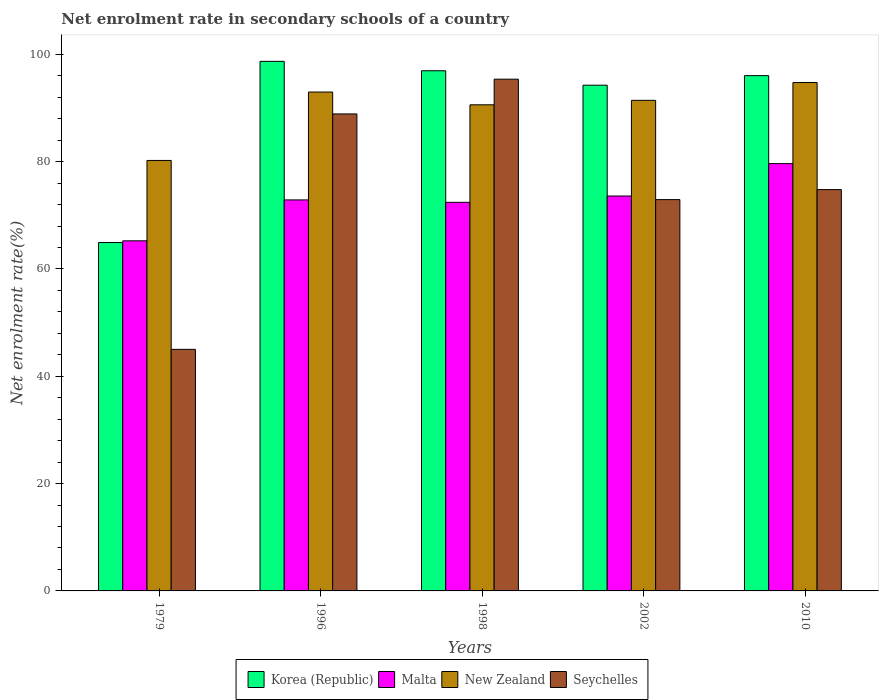How many different coloured bars are there?
Your answer should be compact. 4. How many groups of bars are there?
Ensure brevity in your answer.  5. Are the number of bars per tick equal to the number of legend labels?
Your response must be concise. Yes. How many bars are there on the 4th tick from the right?
Provide a succinct answer. 4. What is the net enrolment rate in secondary schools in Korea (Republic) in 1998?
Ensure brevity in your answer.  96.94. Across all years, what is the maximum net enrolment rate in secondary schools in Malta?
Ensure brevity in your answer.  79.63. Across all years, what is the minimum net enrolment rate in secondary schools in New Zealand?
Keep it short and to the point. 80.22. In which year was the net enrolment rate in secondary schools in Seychelles maximum?
Keep it short and to the point. 1998. In which year was the net enrolment rate in secondary schools in Seychelles minimum?
Your response must be concise. 1979. What is the total net enrolment rate in secondary schools in New Zealand in the graph?
Ensure brevity in your answer.  449.96. What is the difference between the net enrolment rate in secondary schools in Korea (Republic) in 1979 and that in 1998?
Ensure brevity in your answer.  -32.01. What is the difference between the net enrolment rate in secondary schools in Korea (Republic) in 2010 and the net enrolment rate in secondary schools in Seychelles in 1998?
Your answer should be compact. 0.66. What is the average net enrolment rate in secondary schools in Malta per year?
Offer a terse response. 72.75. In the year 2002, what is the difference between the net enrolment rate in secondary schools in Korea (Republic) and net enrolment rate in secondary schools in Malta?
Keep it short and to the point. 20.65. What is the ratio of the net enrolment rate in secondary schools in Seychelles in 1979 to that in 2010?
Make the answer very short. 0.6. What is the difference between the highest and the second highest net enrolment rate in secondary schools in New Zealand?
Provide a short and direct response. 1.78. What is the difference between the highest and the lowest net enrolment rate in secondary schools in New Zealand?
Provide a succinct answer. 14.52. Is the sum of the net enrolment rate in secondary schools in New Zealand in 1996 and 1998 greater than the maximum net enrolment rate in secondary schools in Seychelles across all years?
Provide a succinct answer. Yes. Is it the case that in every year, the sum of the net enrolment rate in secondary schools in Korea (Republic) and net enrolment rate in secondary schools in Malta is greater than the sum of net enrolment rate in secondary schools in Seychelles and net enrolment rate in secondary schools in New Zealand?
Provide a short and direct response. No. What does the 1st bar from the left in 2002 represents?
Provide a succinct answer. Korea (Republic). What does the 1st bar from the right in 2002 represents?
Offer a very short reply. Seychelles. How many bars are there?
Offer a terse response. 20. Are all the bars in the graph horizontal?
Your answer should be compact. No. What is the difference between two consecutive major ticks on the Y-axis?
Keep it short and to the point. 20. Are the values on the major ticks of Y-axis written in scientific E-notation?
Offer a very short reply. No. Does the graph contain any zero values?
Your answer should be very brief. No. How many legend labels are there?
Provide a short and direct response. 4. How are the legend labels stacked?
Ensure brevity in your answer.  Horizontal. What is the title of the graph?
Keep it short and to the point. Net enrolment rate in secondary schools of a country. What is the label or title of the Y-axis?
Your answer should be very brief. Net enrolment rate(%). What is the Net enrolment rate(%) in Korea (Republic) in 1979?
Ensure brevity in your answer.  64.92. What is the Net enrolment rate(%) in Malta in 1979?
Provide a succinct answer. 65.24. What is the Net enrolment rate(%) in New Zealand in 1979?
Ensure brevity in your answer.  80.22. What is the Net enrolment rate(%) in Seychelles in 1979?
Keep it short and to the point. 45.02. What is the Net enrolment rate(%) of Korea (Republic) in 1996?
Your answer should be very brief. 98.69. What is the Net enrolment rate(%) in Malta in 1996?
Keep it short and to the point. 72.87. What is the Net enrolment rate(%) of New Zealand in 1996?
Your answer should be very brief. 92.97. What is the Net enrolment rate(%) in Seychelles in 1996?
Make the answer very short. 88.89. What is the Net enrolment rate(%) in Korea (Republic) in 1998?
Your response must be concise. 96.94. What is the Net enrolment rate(%) in Malta in 1998?
Your response must be concise. 72.42. What is the Net enrolment rate(%) in New Zealand in 1998?
Your answer should be compact. 90.59. What is the Net enrolment rate(%) of Seychelles in 1998?
Keep it short and to the point. 95.37. What is the Net enrolment rate(%) of Korea (Republic) in 2002?
Give a very brief answer. 94.25. What is the Net enrolment rate(%) of Malta in 2002?
Give a very brief answer. 73.6. What is the Net enrolment rate(%) of New Zealand in 2002?
Keep it short and to the point. 91.43. What is the Net enrolment rate(%) of Seychelles in 2002?
Offer a very short reply. 72.93. What is the Net enrolment rate(%) of Korea (Republic) in 2010?
Provide a short and direct response. 96.03. What is the Net enrolment rate(%) of Malta in 2010?
Keep it short and to the point. 79.63. What is the Net enrolment rate(%) in New Zealand in 2010?
Offer a very short reply. 94.75. What is the Net enrolment rate(%) in Seychelles in 2010?
Keep it short and to the point. 74.79. Across all years, what is the maximum Net enrolment rate(%) in Korea (Republic)?
Ensure brevity in your answer.  98.69. Across all years, what is the maximum Net enrolment rate(%) in Malta?
Your answer should be compact. 79.63. Across all years, what is the maximum Net enrolment rate(%) in New Zealand?
Make the answer very short. 94.75. Across all years, what is the maximum Net enrolment rate(%) in Seychelles?
Provide a succinct answer. 95.37. Across all years, what is the minimum Net enrolment rate(%) in Korea (Republic)?
Offer a very short reply. 64.92. Across all years, what is the minimum Net enrolment rate(%) of Malta?
Provide a short and direct response. 65.24. Across all years, what is the minimum Net enrolment rate(%) of New Zealand?
Provide a succinct answer. 80.22. Across all years, what is the minimum Net enrolment rate(%) of Seychelles?
Your response must be concise. 45.02. What is the total Net enrolment rate(%) of Korea (Republic) in the graph?
Provide a short and direct response. 450.83. What is the total Net enrolment rate(%) of Malta in the graph?
Provide a succinct answer. 363.76. What is the total Net enrolment rate(%) of New Zealand in the graph?
Offer a terse response. 449.96. What is the total Net enrolment rate(%) in Seychelles in the graph?
Offer a very short reply. 377. What is the difference between the Net enrolment rate(%) in Korea (Republic) in 1979 and that in 1996?
Provide a succinct answer. -33.77. What is the difference between the Net enrolment rate(%) in Malta in 1979 and that in 1996?
Ensure brevity in your answer.  -7.62. What is the difference between the Net enrolment rate(%) of New Zealand in 1979 and that in 1996?
Provide a succinct answer. -12.75. What is the difference between the Net enrolment rate(%) of Seychelles in 1979 and that in 1996?
Your response must be concise. -43.87. What is the difference between the Net enrolment rate(%) of Korea (Republic) in 1979 and that in 1998?
Give a very brief answer. -32.01. What is the difference between the Net enrolment rate(%) of Malta in 1979 and that in 1998?
Provide a succinct answer. -7.18. What is the difference between the Net enrolment rate(%) in New Zealand in 1979 and that in 1998?
Offer a terse response. -10.37. What is the difference between the Net enrolment rate(%) in Seychelles in 1979 and that in 1998?
Provide a succinct answer. -50.35. What is the difference between the Net enrolment rate(%) of Korea (Republic) in 1979 and that in 2002?
Offer a very short reply. -29.32. What is the difference between the Net enrolment rate(%) of Malta in 1979 and that in 2002?
Give a very brief answer. -8.35. What is the difference between the Net enrolment rate(%) in New Zealand in 1979 and that in 2002?
Your answer should be compact. -11.2. What is the difference between the Net enrolment rate(%) of Seychelles in 1979 and that in 2002?
Provide a short and direct response. -27.91. What is the difference between the Net enrolment rate(%) in Korea (Republic) in 1979 and that in 2010?
Ensure brevity in your answer.  -31.11. What is the difference between the Net enrolment rate(%) of Malta in 1979 and that in 2010?
Provide a short and direct response. -14.39. What is the difference between the Net enrolment rate(%) of New Zealand in 1979 and that in 2010?
Ensure brevity in your answer.  -14.52. What is the difference between the Net enrolment rate(%) of Seychelles in 1979 and that in 2010?
Provide a short and direct response. -29.77. What is the difference between the Net enrolment rate(%) in Korea (Republic) in 1996 and that in 1998?
Make the answer very short. 1.75. What is the difference between the Net enrolment rate(%) in Malta in 1996 and that in 1998?
Give a very brief answer. 0.45. What is the difference between the Net enrolment rate(%) of New Zealand in 1996 and that in 1998?
Your response must be concise. 2.38. What is the difference between the Net enrolment rate(%) of Seychelles in 1996 and that in 1998?
Give a very brief answer. -6.47. What is the difference between the Net enrolment rate(%) of Korea (Republic) in 1996 and that in 2002?
Offer a very short reply. 4.44. What is the difference between the Net enrolment rate(%) in Malta in 1996 and that in 2002?
Your answer should be very brief. -0.73. What is the difference between the Net enrolment rate(%) in New Zealand in 1996 and that in 2002?
Provide a succinct answer. 1.54. What is the difference between the Net enrolment rate(%) of Seychelles in 1996 and that in 2002?
Make the answer very short. 15.97. What is the difference between the Net enrolment rate(%) of Korea (Republic) in 1996 and that in 2010?
Your answer should be very brief. 2.66. What is the difference between the Net enrolment rate(%) of Malta in 1996 and that in 2010?
Ensure brevity in your answer.  -6.77. What is the difference between the Net enrolment rate(%) of New Zealand in 1996 and that in 2010?
Make the answer very short. -1.78. What is the difference between the Net enrolment rate(%) of Seychelles in 1996 and that in 2010?
Offer a very short reply. 14.1. What is the difference between the Net enrolment rate(%) in Korea (Republic) in 1998 and that in 2002?
Your answer should be compact. 2.69. What is the difference between the Net enrolment rate(%) of Malta in 1998 and that in 2002?
Your answer should be compact. -1.17. What is the difference between the Net enrolment rate(%) of New Zealand in 1998 and that in 2002?
Your answer should be very brief. -0.83. What is the difference between the Net enrolment rate(%) of Seychelles in 1998 and that in 2002?
Give a very brief answer. 22.44. What is the difference between the Net enrolment rate(%) in Korea (Republic) in 1998 and that in 2010?
Provide a succinct answer. 0.91. What is the difference between the Net enrolment rate(%) of Malta in 1998 and that in 2010?
Your answer should be very brief. -7.21. What is the difference between the Net enrolment rate(%) of New Zealand in 1998 and that in 2010?
Your answer should be very brief. -4.15. What is the difference between the Net enrolment rate(%) of Seychelles in 1998 and that in 2010?
Your answer should be compact. 20.57. What is the difference between the Net enrolment rate(%) in Korea (Republic) in 2002 and that in 2010?
Your response must be concise. -1.78. What is the difference between the Net enrolment rate(%) in Malta in 2002 and that in 2010?
Offer a very short reply. -6.04. What is the difference between the Net enrolment rate(%) of New Zealand in 2002 and that in 2010?
Provide a short and direct response. -3.32. What is the difference between the Net enrolment rate(%) of Seychelles in 2002 and that in 2010?
Your response must be concise. -1.87. What is the difference between the Net enrolment rate(%) of Korea (Republic) in 1979 and the Net enrolment rate(%) of Malta in 1996?
Make the answer very short. -7.95. What is the difference between the Net enrolment rate(%) of Korea (Republic) in 1979 and the Net enrolment rate(%) of New Zealand in 1996?
Make the answer very short. -28.05. What is the difference between the Net enrolment rate(%) of Korea (Republic) in 1979 and the Net enrolment rate(%) of Seychelles in 1996?
Make the answer very short. -23.97. What is the difference between the Net enrolment rate(%) of Malta in 1979 and the Net enrolment rate(%) of New Zealand in 1996?
Your answer should be very brief. -27.73. What is the difference between the Net enrolment rate(%) of Malta in 1979 and the Net enrolment rate(%) of Seychelles in 1996?
Make the answer very short. -23.65. What is the difference between the Net enrolment rate(%) in New Zealand in 1979 and the Net enrolment rate(%) in Seychelles in 1996?
Your answer should be very brief. -8.67. What is the difference between the Net enrolment rate(%) of Korea (Republic) in 1979 and the Net enrolment rate(%) of Malta in 1998?
Offer a very short reply. -7.5. What is the difference between the Net enrolment rate(%) of Korea (Republic) in 1979 and the Net enrolment rate(%) of New Zealand in 1998?
Give a very brief answer. -25.67. What is the difference between the Net enrolment rate(%) in Korea (Republic) in 1979 and the Net enrolment rate(%) in Seychelles in 1998?
Provide a succinct answer. -30.44. What is the difference between the Net enrolment rate(%) in Malta in 1979 and the Net enrolment rate(%) in New Zealand in 1998?
Offer a very short reply. -25.35. What is the difference between the Net enrolment rate(%) of Malta in 1979 and the Net enrolment rate(%) of Seychelles in 1998?
Ensure brevity in your answer.  -30.12. What is the difference between the Net enrolment rate(%) of New Zealand in 1979 and the Net enrolment rate(%) of Seychelles in 1998?
Keep it short and to the point. -15.14. What is the difference between the Net enrolment rate(%) of Korea (Republic) in 1979 and the Net enrolment rate(%) of Malta in 2002?
Keep it short and to the point. -8.67. What is the difference between the Net enrolment rate(%) of Korea (Republic) in 1979 and the Net enrolment rate(%) of New Zealand in 2002?
Make the answer very short. -26.5. What is the difference between the Net enrolment rate(%) of Korea (Republic) in 1979 and the Net enrolment rate(%) of Seychelles in 2002?
Make the answer very short. -8. What is the difference between the Net enrolment rate(%) in Malta in 1979 and the Net enrolment rate(%) in New Zealand in 2002?
Provide a short and direct response. -26.18. What is the difference between the Net enrolment rate(%) of Malta in 1979 and the Net enrolment rate(%) of Seychelles in 2002?
Provide a short and direct response. -7.68. What is the difference between the Net enrolment rate(%) in New Zealand in 1979 and the Net enrolment rate(%) in Seychelles in 2002?
Your answer should be compact. 7.3. What is the difference between the Net enrolment rate(%) in Korea (Republic) in 1979 and the Net enrolment rate(%) in Malta in 2010?
Offer a terse response. -14.71. What is the difference between the Net enrolment rate(%) in Korea (Republic) in 1979 and the Net enrolment rate(%) in New Zealand in 2010?
Provide a short and direct response. -29.82. What is the difference between the Net enrolment rate(%) in Korea (Republic) in 1979 and the Net enrolment rate(%) in Seychelles in 2010?
Provide a short and direct response. -9.87. What is the difference between the Net enrolment rate(%) in Malta in 1979 and the Net enrolment rate(%) in New Zealand in 2010?
Your response must be concise. -29.5. What is the difference between the Net enrolment rate(%) in Malta in 1979 and the Net enrolment rate(%) in Seychelles in 2010?
Make the answer very short. -9.55. What is the difference between the Net enrolment rate(%) of New Zealand in 1979 and the Net enrolment rate(%) of Seychelles in 2010?
Give a very brief answer. 5.43. What is the difference between the Net enrolment rate(%) of Korea (Republic) in 1996 and the Net enrolment rate(%) of Malta in 1998?
Ensure brevity in your answer.  26.27. What is the difference between the Net enrolment rate(%) of Korea (Republic) in 1996 and the Net enrolment rate(%) of New Zealand in 1998?
Provide a succinct answer. 8.1. What is the difference between the Net enrolment rate(%) in Korea (Republic) in 1996 and the Net enrolment rate(%) in Seychelles in 1998?
Your response must be concise. 3.32. What is the difference between the Net enrolment rate(%) of Malta in 1996 and the Net enrolment rate(%) of New Zealand in 1998?
Offer a very short reply. -17.72. What is the difference between the Net enrolment rate(%) in Malta in 1996 and the Net enrolment rate(%) in Seychelles in 1998?
Offer a terse response. -22.5. What is the difference between the Net enrolment rate(%) of New Zealand in 1996 and the Net enrolment rate(%) of Seychelles in 1998?
Keep it short and to the point. -2.4. What is the difference between the Net enrolment rate(%) in Korea (Republic) in 1996 and the Net enrolment rate(%) in Malta in 2002?
Give a very brief answer. 25.1. What is the difference between the Net enrolment rate(%) of Korea (Republic) in 1996 and the Net enrolment rate(%) of New Zealand in 2002?
Keep it short and to the point. 7.26. What is the difference between the Net enrolment rate(%) in Korea (Republic) in 1996 and the Net enrolment rate(%) in Seychelles in 2002?
Ensure brevity in your answer.  25.76. What is the difference between the Net enrolment rate(%) in Malta in 1996 and the Net enrolment rate(%) in New Zealand in 2002?
Offer a very short reply. -18.56. What is the difference between the Net enrolment rate(%) of Malta in 1996 and the Net enrolment rate(%) of Seychelles in 2002?
Your answer should be very brief. -0.06. What is the difference between the Net enrolment rate(%) in New Zealand in 1996 and the Net enrolment rate(%) in Seychelles in 2002?
Make the answer very short. 20.04. What is the difference between the Net enrolment rate(%) of Korea (Republic) in 1996 and the Net enrolment rate(%) of Malta in 2010?
Give a very brief answer. 19.06. What is the difference between the Net enrolment rate(%) of Korea (Republic) in 1996 and the Net enrolment rate(%) of New Zealand in 2010?
Provide a short and direct response. 3.94. What is the difference between the Net enrolment rate(%) of Korea (Republic) in 1996 and the Net enrolment rate(%) of Seychelles in 2010?
Offer a very short reply. 23.9. What is the difference between the Net enrolment rate(%) of Malta in 1996 and the Net enrolment rate(%) of New Zealand in 2010?
Your answer should be compact. -21.88. What is the difference between the Net enrolment rate(%) of Malta in 1996 and the Net enrolment rate(%) of Seychelles in 2010?
Ensure brevity in your answer.  -1.93. What is the difference between the Net enrolment rate(%) in New Zealand in 1996 and the Net enrolment rate(%) in Seychelles in 2010?
Your answer should be compact. 18.18. What is the difference between the Net enrolment rate(%) of Korea (Republic) in 1998 and the Net enrolment rate(%) of Malta in 2002?
Your response must be concise. 23.34. What is the difference between the Net enrolment rate(%) in Korea (Republic) in 1998 and the Net enrolment rate(%) in New Zealand in 2002?
Your answer should be compact. 5.51. What is the difference between the Net enrolment rate(%) of Korea (Republic) in 1998 and the Net enrolment rate(%) of Seychelles in 2002?
Give a very brief answer. 24.01. What is the difference between the Net enrolment rate(%) in Malta in 1998 and the Net enrolment rate(%) in New Zealand in 2002?
Ensure brevity in your answer.  -19.01. What is the difference between the Net enrolment rate(%) in Malta in 1998 and the Net enrolment rate(%) in Seychelles in 2002?
Offer a terse response. -0.51. What is the difference between the Net enrolment rate(%) in New Zealand in 1998 and the Net enrolment rate(%) in Seychelles in 2002?
Your response must be concise. 17.66. What is the difference between the Net enrolment rate(%) of Korea (Republic) in 1998 and the Net enrolment rate(%) of Malta in 2010?
Make the answer very short. 17.3. What is the difference between the Net enrolment rate(%) in Korea (Republic) in 1998 and the Net enrolment rate(%) in New Zealand in 2010?
Your response must be concise. 2.19. What is the difference between the Net enrolment rate(%) of Korea (Republic) in 1998 and the Net enrolment rate(%) of Seychelles in 2010?
Keep it short and to the point. 22.14. What is the difference between the Net enrolment rate(%) in Malta in 1998 and the Net enrolment rate(%) in New Zealand in 2010?
Your response must be concise. -22.33. What is the difference between the Net enrolment rate(%) in Malta in 1998 and the Net enrolment rate(%) in Seychelles in 2010?
Provide a succinct answer. -2.37. What is the difference between the Net enrolment rate(%) in New Zealand in 1998 and the Net enrolment rate(%) in Seychelles in 2010?
Your response must be concise. 15.8. What is the difference between the Net enrolment rate(%) of Korea (Republic) in 2002 and the Net enrolment rate(%) of Malta in 2010?
Offer a very short reply. 14.61. What is the difference between the Net enrolment rate(%) of Korea (Republic) in 2002 and the Net enrolment rate(%) of New Zealand in 2010?
Keep it short and to the point. -0.5. What is the difference between the Net enrolment rate(%) in Korea (Republic) in 2002 and the Net enrolment rate(%) in Seychelles in 2010?
Provide a succinct answer. 19.45. What is the difference between the Net enrolment rate(%) of Malta in 2002 and the Net enrolment rate(%) of New Zealand in 2010?
Give a very brief answer. -21.15. What is the difference between the Net enrolment rate(%) of Malta in 2002 and the Net enrolment rate(%) of Seychelles in 2010?
Ensure brevity in your answer.  -1.2. What is the difference between the Net enrolment rate(%) of New Zealand in 2002 and the Net enrolment rate(%) of Seychelles in 2010?
Give a very brief answer. 16.63. What is the average Net enrolment rate(%) of Korea (Republic) per year?
Offer a terse response. 90.17. What is the average Net enrolment rate(%) in Malta per year?
Your answer should be very brief. 72.75. What is the average Net enrolment rate(%) in New Zealand per year?
Your answer should be very brief. 89.99. What is the average Net enrolment rate(%) of Seychelles per year?
Provide a short and direct response. 75.4. In the year 1979, what is the difference between the Net enrolment rate(%) of Korea (Republic) and Net enrolment rate(%) of Malta?
Your answer should be very brief. -0.32. In the year 1979, what is the difference between the Net enrolment rate(%) of Korea (Republic) and Net enrolment rate(%) of New Zealand?
Provide a succinct answer. -15.3. In the year 1979, what is the difference between the Net enrolment rate(%) in Korea (Republic) and Net enrolment rate(%) in Seychelles?
Offer a very short reply. 19.9. In the year 1979, what is the difference between the Net enrolment rate(%) in Malta and Net enrolment rate(%) in New Zealand?
Your answer should be compact. -14.98. In the year 1979, what is the difference between the Net enrolment rate(%) of Malta and Net enrolment rate(%) of Seychelles?
Your answer should be very brief. 20.22. In the year 1979, what is the difference between the Net enrolment rate(%) in New Zealand and Net enrolment rate(%) in Seychelles?
Offer a very short reply. 35.2. In the year 1996, what is the difference between the Net enrolment rate(%) in Korea (Republic) and Net enrolment rate(%) in Malta?
Your response must be concise. 25.82. In the year 1996, what is the difference between the Net enrolment rate(%) of Korea (Republic) and Net enrolment rate(%) of New Zealand?
Offer a terse response. 5.72. In the year 1996, what is the difference between the Net enrolment rate(%) of Korea (Republic) and Net enrolment rate(%) of Seychelles?
Your answer should be very brief. 9.8. In the year 1996, what is the difference between the Net enrolment rate(%) in Malta and Net enrolment rate(%) in New Zealand?
Your answer should be very brief. -20.1. In the year 1996, what is the difference between the Net enrolment rate(%) of Malta and Net enrolment rate(%) of Seychelles?
Your response must be concise. -16.02. In the year 1996, what is the difference between the Net enrolment rate(%) of New Zealand and Net enrolment rate(%) of Seychelles?
Ensure brevity in your answer.  4.08. In the year 1998, what is the difference between the Net enrolment rate(%) of Korea (Republic) and Net enrolment rate(%) of Malta?
Give a very brief answer. 24.52. In the year 1998, what is the difference between the Net enrolment rate(%) of Korea (Republic) and Net enrolment rate(%) of New Zealand?
Offer a very short reply. 6.35. In the year 1998, what is the difference between the Net enrolment rate(%) in Korea (Republic) and Net enrolment rate(%) in Seychelles?
Your answer should be compact. 1.57. In the year 1998, what is the difference between the Net enrolment rate(%) in Malta and Net enrolment rate(%) in New Zealand?
Your response must be concise. -18.17. In the year 1998, what is the difference between the Net enrolment rate(%) of Malta and Net enrolment rate(%) of Seychelles?
Your answer should be very brief. -22.95. In the year 1998, what is the difference between the Net enrolment rate(%) of New Zealand and Net enrolment rate(%) of Seychelles?
Provide a short and direct response. -4.78. In the year 2002, what is the difference between the Net enrolment rate(%) of Korea (Republic) and Net enrolment rate(%) of Malta?
Your answer should be very brief. 20.65. In the year 2002, what is the difference between the Net enrolment rate(%) of Korea (Republic) and Net enrolment rate(%) of New Zealand?
Your answer should be very brief. 2.82. In the year 2002, what is the difference between the Net enrolment rate(%) of Korea (Republic) and Net enrolment rate(%) of Seychelles?
Your response must be concise. 21.32. In the year 2002, what is the difference between the Net enrolment rate(%) in Malta and Net enrolment rate(%) in New Zealand?
Your answer should be very brief. -17.83. In the year 2002, what is the difference between the Net enrolment rate(%) of Malta and Net enrolment rate(%) of Seychelles?
Ensure brevity in your answer.  0.67. In the year 2002, what is the difference between the Net enrolment rate(%) of New Zealand and Net enrolment rate(%) of Seychelles?
Offer a very short reply. 18.5. In the year 2010, what is the difference between the Net enrolment rate(%) in Korea (Republic) and Net enrolment rate(%) in Malta?
Offer a very short reply. 16.39. In the year 2010, what is the difference between the Net enrolment rate(%) of Korea (Republic) and Net enrolment rate(%) of New Zealand?
Keep it short and to the point. 1.28. In the year 2010, what is the difference between the Net enrolment rate(%) of Korea (Republic) and Net enrolment rate(%) of Seychelles?
Give a very brief answer. 21.24. In the year 2010, what is the difference between the Net enrolment rate(%) of Malta and Net enrolment rate(%) of New Zealand?
Ensure brevity in your answer.  -15.11. In the year 2010, what is the difference between the Net enrolment rate(%) in Malta and Net enrolment rate(%) in Seychelles?
Your answer should be very brief. 4.84. In the year 2010, what is the difference between the Net enrolment rate(%) of New Zealand and Net enrolment rate(%) of Seychelles?
Provide a succinct answer. 19.95. What is the ratio of the Net enrolment rate(%) in Korea (Republic) in 1979 to that in 1996?
Offer a very short reply. 0.66. What is the ratio of the Net enrolment rate(%) of Malta in 1979 to that in 1996?
Offer a terse response. 0.9. What is the ratio of the Net enrolment rate(%) of New Zealand in 1979 to that in 1996?
Provide a succinct answer. 0.86. What is the ratio of the Net enrolment rate(%) of Seychelles in 1979 to that in 1996?
Your response must be concise. 0.51. What is the ratio of the Net enrolment rate(%) of Korea (Republic) in 1979 to that in 1998?
Keep it short and to the point. 0.67. What is the ratio of the Net enrolment rate(%) in Malta in 1979 to that in 1998?
Offer a terse response. 0.9. What is the ratio of the Net enrolment rate(%) of New Zealand in 1979 to that in 1998?
Provide a succinct answer. 0.89. What is the ratio of the Net enrolment rate(%) of Seychelles in 1979 to that in 1998?
Keep it short and to the point. 0.47. What is the ratio of the Net enrolment rate(%) in Korea (Republic) in 1979 to that in 2002?
Ensure brevity in your answer.  0.69. What is the ratio of the Net enrolment rate(%) of Malta in 1979 to that in 2002?
Ensure brevity in your answer.  0.89. What is the ratio of the Net enrolment rate(%) in New Zealand in 1979 to that in 2002?
Your answer should be compact. 0.88. What is the ratio of the Net enrolment rate(%) of Seychelles in 1979 to that in 2002?
Your answer should be very brief. 0.62. What is the ratio of the Net enrolment rate(%) in Korea (Republic) in 1979 to that in 2010?
Your answer should be compact. 0.68. What is the ratio of the Net enrolment rate(%) in Malta in 1979 to that in 2010?
Make the answer very short. 0.82. What is the ratio of the Net enrolment rate(%) in New Zealand in 1979 to that in 2010?
Your answer should be very brief. 0.85. What is the ratio of the Net enrolment rate(%) in Seychelles in 1979 to that in 2010?
Make the answer very short. 0.6. What is the ratio of the Net enrolment rate(%) of Korea (Republic) in 1996 to that in 1998?
Keep it short and to the point. 1.02. What is the ratio of the Net enrolment rate(%) of Malta in 1996 to that in 1998?
Offer a very short reply. 1.01. What is the ratio of the Net enrolment rate(%) of New Zealand in 1996 to that in 1998?
Your answer should be compact. 1.03. What is the ratio of the Net enrolment rate(%) in Seychelles in 1996 to that in 1998?
Offer a very short reply. 0.93. What is the ratio of the Net enrolment rate(%) in Korea (Republic) in 1996 to that in 2002?
Ensure brevity in your answer.  1.05. What is the ratio of the Net enrolment rate(%) of Malta in 1996 to that in 2002?
Keep it short and to the point. 0.99. What is the ratio of the Net enrolment rate(%) of New Zealand in 1996 to that in 2002?
Your response must be concise. 1.02. What is the ratio of the Net enrolment rate(%) of Seychelles in 1996 to that in 2002?
Your answer should be compact. 1.22. What is the ratio of the Net enrolment rate(%) in Korea (Republic) in 1996 to that in 2010?
Your response must be concise. 1.03. What is the ratio of the Net enrolment rate(%) of Malta in 1996 to that in 2010?
Offer a terse response. 0.92. What is the ratio of the Net enrolment rate(%) of New Zealand in 1996 to that in 2010?
Provide a succinct answer. 0.98. What is the ratio of the Net enrolment rate(%) of Seychelles in 1996 to that in 2010?
Ensure brevity in your answer.  1.19. What is the ratio of the Net enrolment rate(%) of Korea (Republic) in 1998 to that in 2002?
Your answer should be compact. 1.03. What is the ratio of the Net enrolment rate(%) of Malta in 1998 to that in 2002?
Ensure brevity in your answer.  0.98. What is the ratio of the Net enrolment rate(%) in New Zealand in 1998 to that in 2002?
Ensure brevity in your answer.  0.99. What is the ratio of the Net enrolment rate(%) of Seychelles in 1998 to that in 2002?
Offer a terse response. 1.31. What is the ratio of the Net enrolment rate(%) in Korea (Republic) in 1998 to that in 2010?
Ensure brevity in your answer.  1.01. What is the ratio of the Net enrolment rate(%) in Malta in 1998 to that in 2010?
Ensure brevity in your answer.  0.91. What is the ratio of the Net enrolment rate(%) of New Zealand in 1998 to that in 2010?
Make the answer very short. 0.96. What is the ratio of the Net enrolment rate(%) of Seychelles in 1998 to that in 2010?
Give a very brief answer. 1.28. What is the ratio of the Net enrolment rate(%) of Korea (Republic) in 2002 to that in 2010?
Provide a short and direct response. 0.98. What is the ratio of the Net enrolment rate(%) of Malta in 2002 to that in 2010?
Give a very brief answer. 0.92. What is the ratio of the Net enrolment rate(%) of New Zealand in 2002 to that in 2010?
Provide a succinct answer. 0.96. What is the ratio of the Net enrolment rate(%) in Seychelles in 2002 to that in 2010?
Offer a terse response. 0.97. What is the difference between the highest and the second highest Net enrolment rate(%) of Korea (Republic)?
Give a very brief answer. 1.75. What is the difference between the highest and the second highest Net enrolment rate(%) of Malta?
Give a very brief answer. 6.04. What is the difference between the highest and the second highest Net enrolment rate(%) of New Zealand?
Offer a very short reply. 1.78. What is the difference between the highest and the second highest Net enrolment rate(%) in Seychelles?
Your response must be concise. 6.47. What is the difference between the highest and the lowest Net enrolment rate(%) of Korea (Republic)?
Your answer should be very brief. 33.77. What is the difference between the highest and the lowest Net enrolment rate(%) of Malta?
Offer a terse response. 14.39. What is the difference between the highest and the lowest Net enrolment rate(%) in New Zealand?
Offer a terse response. 14.52. What is the difference between the highest and the lowest Net enrolment rate(%) of Seychelles?
Give a very brief answer. 50.35. 